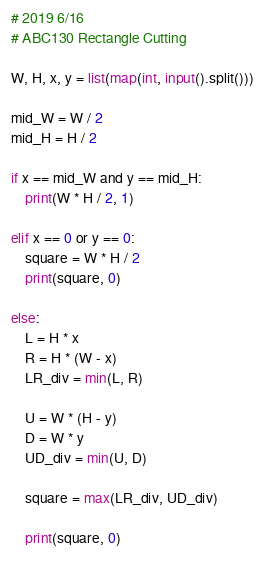Convert code to text. <code><loc_0><loc_0><loc_500><loc_500><_Python_># 2019 6/16
# ABC130 Rectangle Cutting

W, H, x, y = list(map(int, input().split()))

mid_W = W / 2
mid_H = H / 2

if x == mid_W and y == mid_H:
    print(W * H / 2, 1)

elif x == 0 or y == 0:
    square = W * H / 2
    print(square, 0)

else:
    L = H * x
    R = H * (W - x)
    LR_div = min(L, R)

    U = W * (H - y)
    D = W * y
    UD_div = min(U, D)

    square = max(LR_div, UD_div)

    print(square, 0)
</code> 